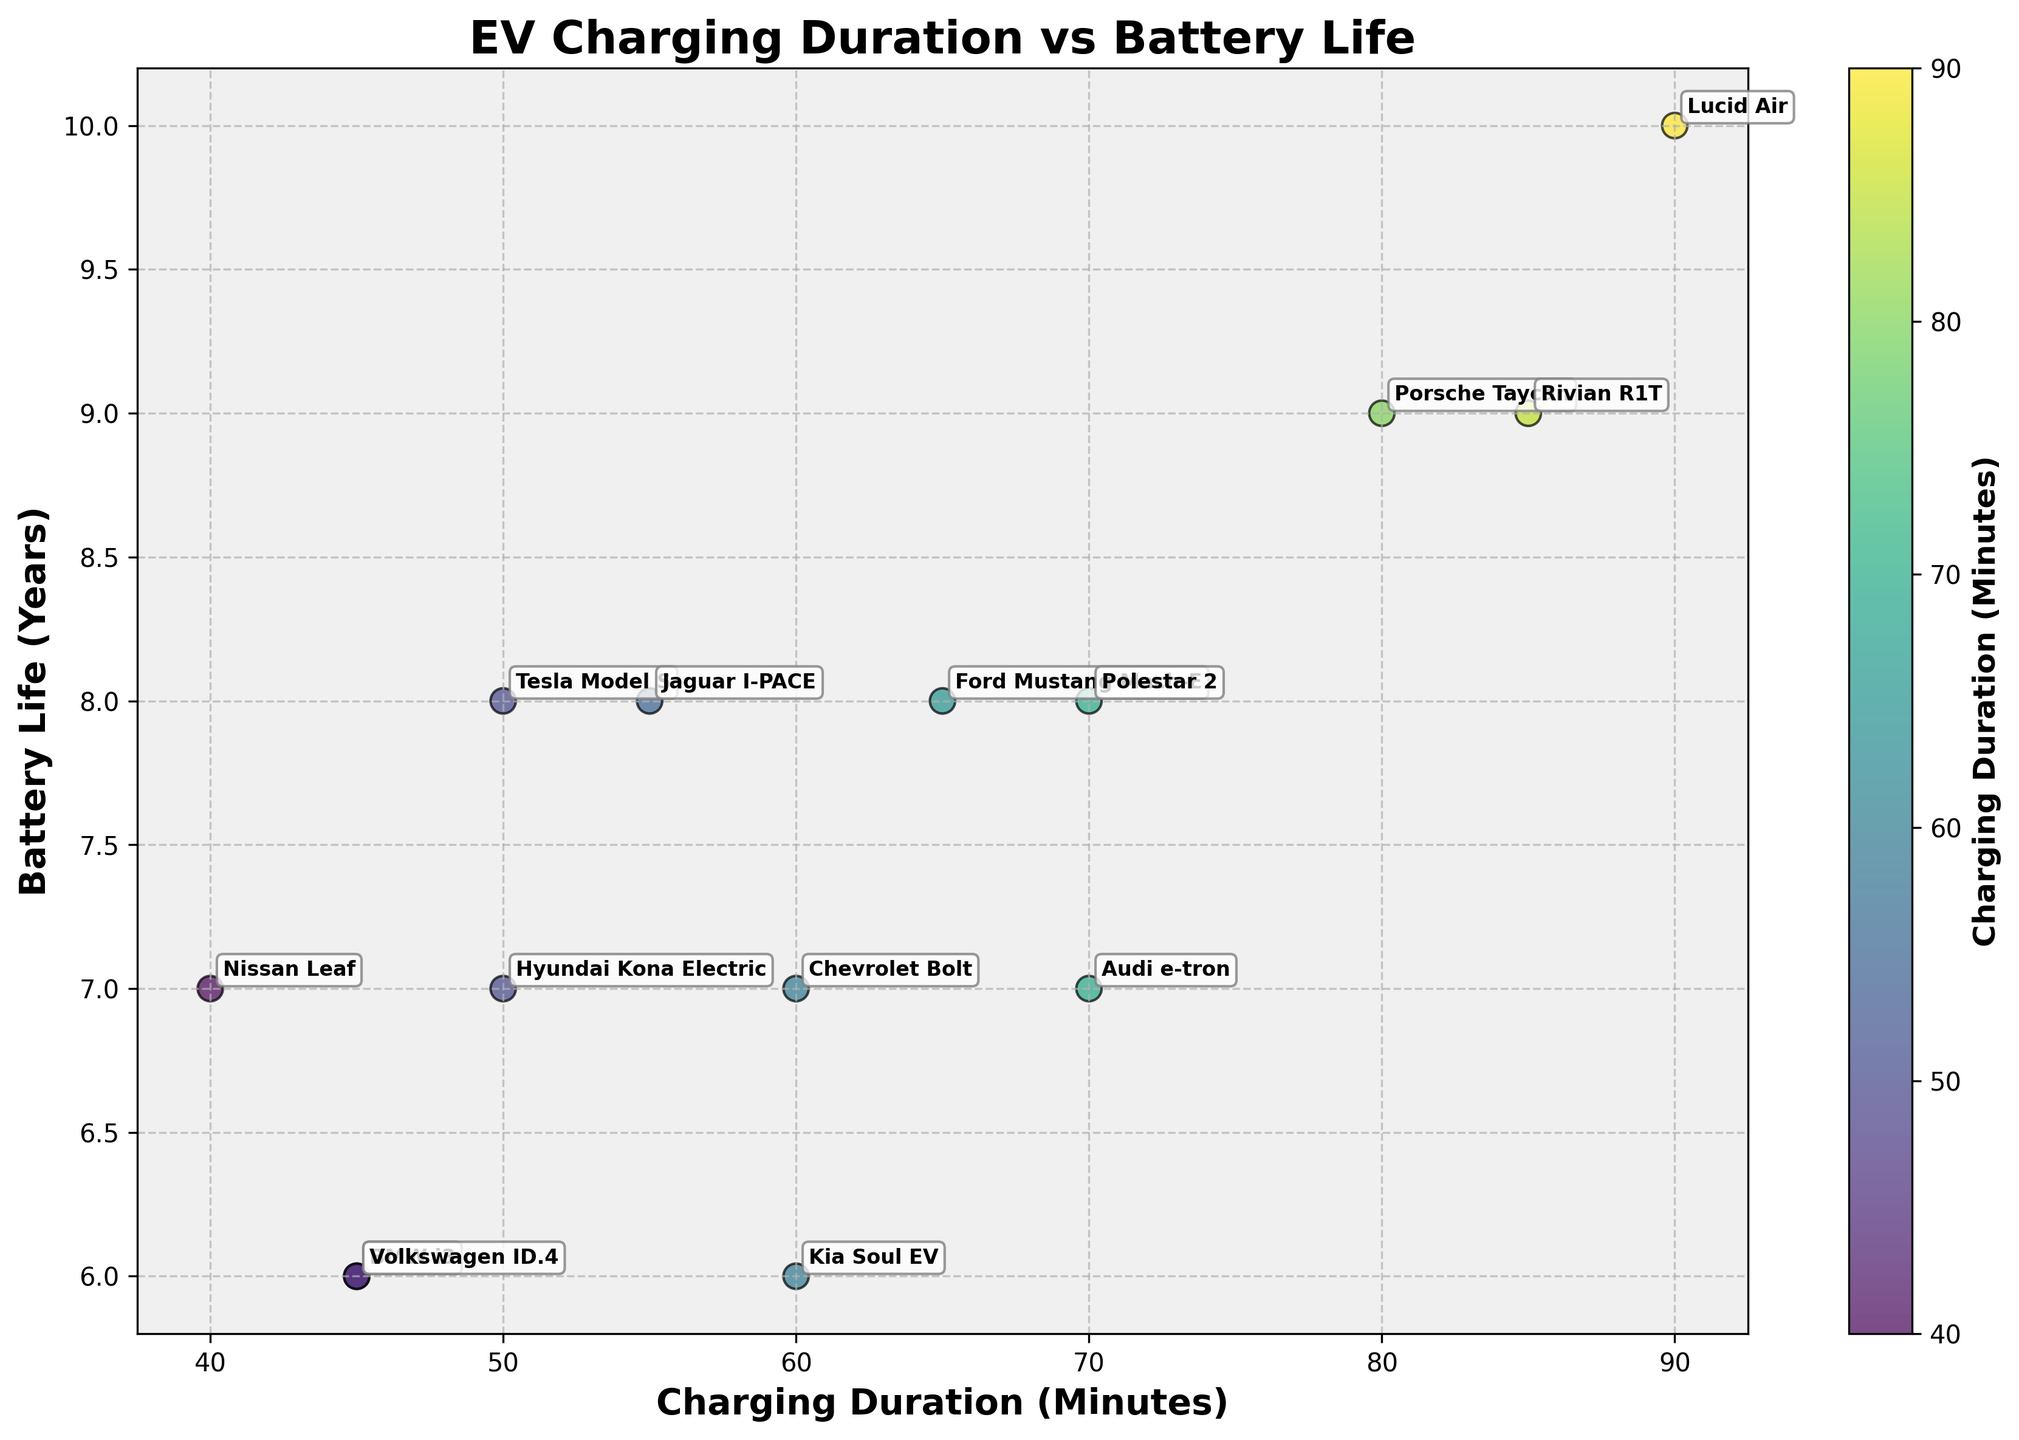Which EV model has the highest battery life? By observing the scatter plot, find the point located at the highest position on the y-axis (Battery Life) and check the corresponding model name annotated near it.
Answer: Lucid Air What's the title of the scatter plot? The title is typically positioned at the top of the plot, centrally aligned in a larger font than other text.
Answer: EV Charging Duration vs Battery Life Which model has a charging duration of 70 minutes and a battery life of 8 years? Look for the data point where the x-coordinate (Charging Duration) is 70 and the y-coordinate (Battery Life) is 8, then check the annotation for the model name.
Answer: Polestar 2 How many models have a battery life equal to or greater than 8 years? Count the number of data points on or above the y-coordinate value of 8 and refer to the annotations to ensure they represent different models.
Answer: 5 Which model has the shortest charging duration but a battery life of 7 years? Identify the data point with the minimum x-coordinate (Charging Duration), then check the y-coordinate (Battery Life) equals 7 and read the annotation for the model name.
Answer: Nissan Leaf What's the range of charging durations for vehicles that have a battery life of 7 years? Locate all points where y-coordinate (Battery Life) equals 7, note the corresponding x-coordinates (Charging Duration), and then find the difference between the maximum and minimum values among these points.
Answer: 30 minutes Is there a positive correlation between charging duration and battery life in this scatter plot? Assess whether the data points tend to increase in battery life as the charging duration increases. A visible upward trend suggests a positive correlation.
Answer: Yes Which model has the longest charging duration? Identify the point located at the farthest right on the x-axis (Charging Duration) and check the annotation for the model name.
Answer: Lucid Air What is the average battery life of all models in the scatter plot? Sum the battery life values of all models and divide by the number of models to find the average. Reviewing the data table, sum (8, 7, 7, 6, 8, 7, 7, 6, 9, 8, 6, 8, 9, 10) / 14
Answer: 7.5 years How does the charging duration for Tesla Model S compare to Volkswagen ID.4? Identify the coordinates for Tesla Model S and Volkswagen ID.4, and compare their x-coordinates (Charging Duration).
Answer: Tesla Model S has a longer charging duration 